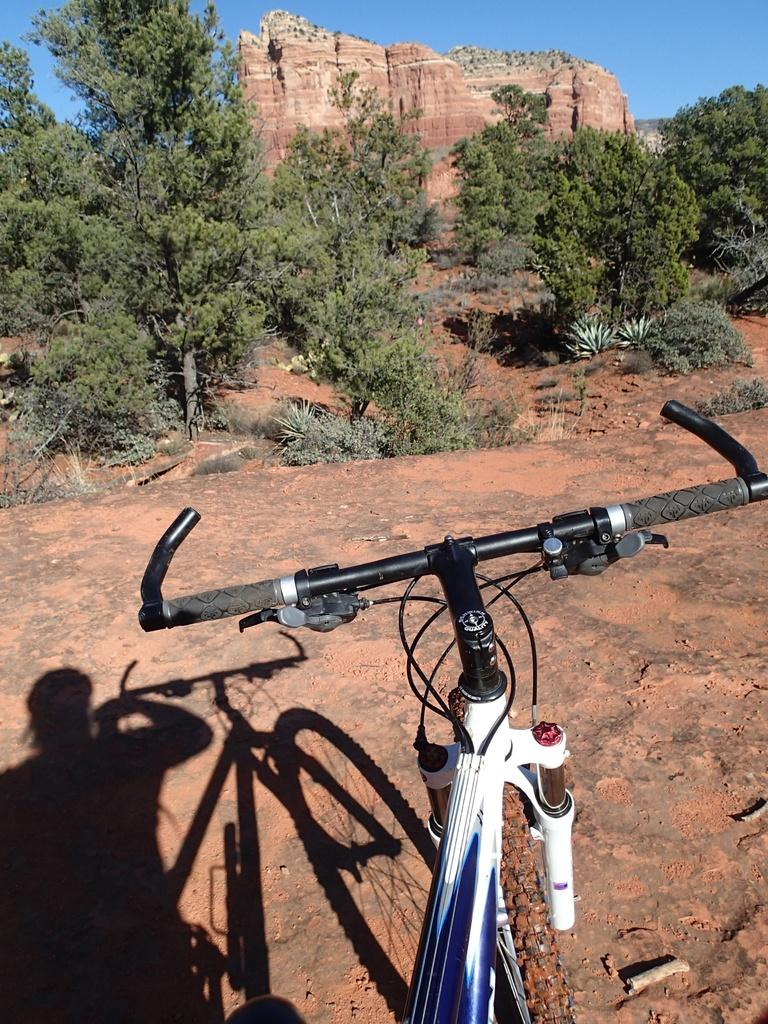What is the main object in the image? There is a cycle in the image. Can you describe anything related to a person in the image? There is a shadow of a person beside the cycle. What type of natural elements can be seen in the background of the image? There are plants, trees, and rocks in the background of the image. What part of the natural environment is visible in the image? The sky is visible in the background of the image. What type of box is being used to shape the trees in the image? There is no box present in the image, and the trees are not being shaped by any object. 